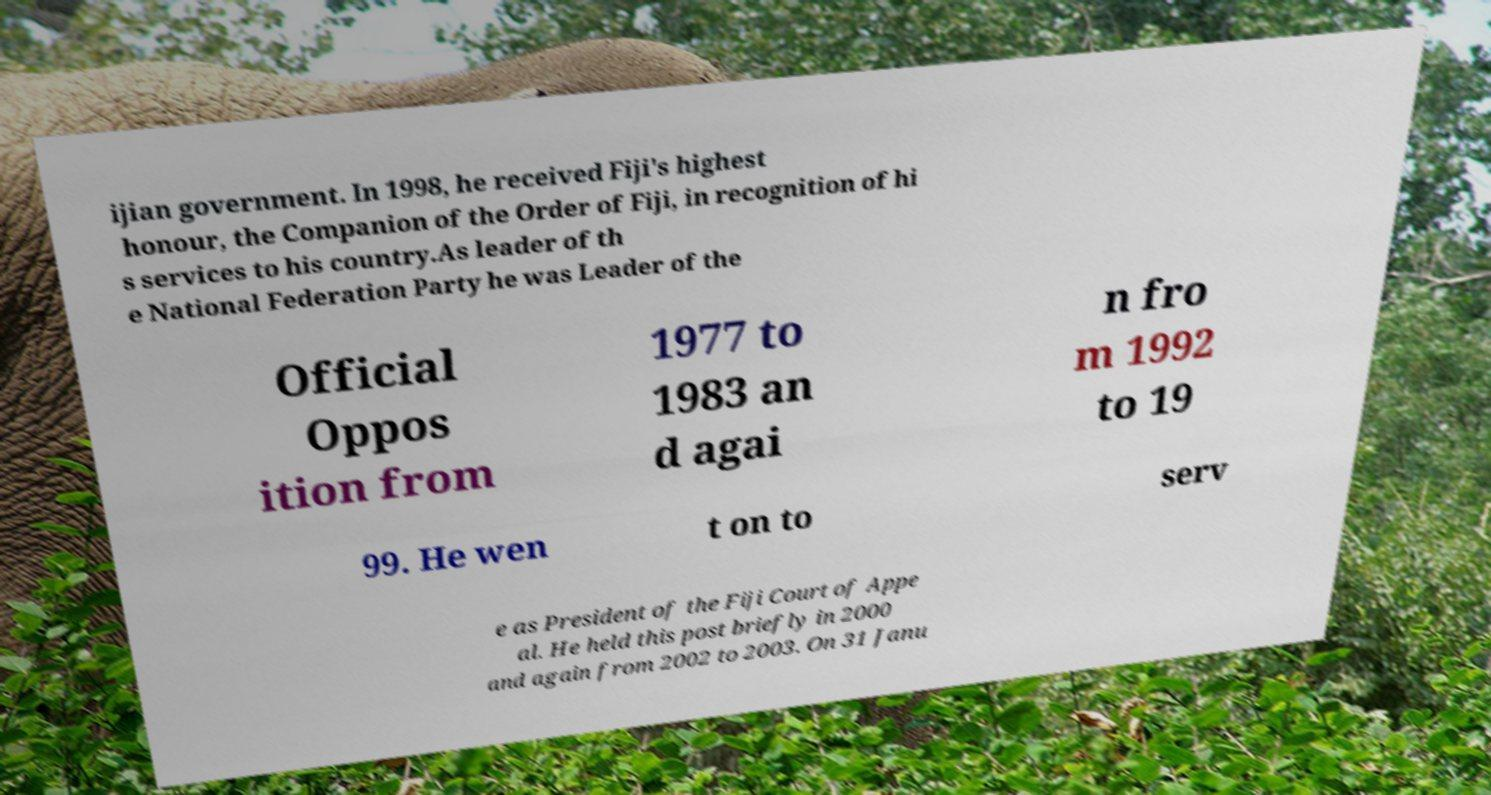Could you assist in decoding the text presented in this image and type it out clearly? ijian government. In 1998, he received Fiji's highest honour, the Companion of the Order of Fiji, in recognition of hi s services to his country.As leader of th e National Federation Party he was Leader of the Official Oppos ition from 1977 to 1983 an d agai n fro m 1992 to 19 99. He wen t on to serv e as President of the Fiji Court of Appe al. He held this post briefly in 2000 and again from 2002 to 2003. On 31 Janu 